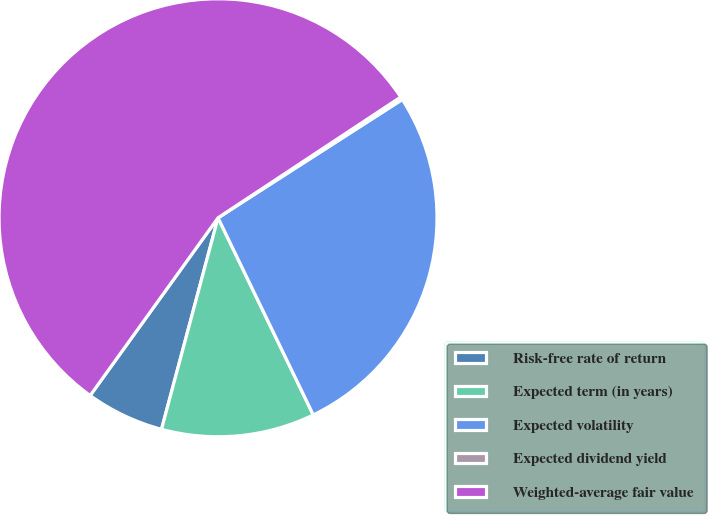Convert chart to OTSL. <chart><loc_0><loc_0><loc_500><loc_500><pie_chart><fcel>Risk-free rate of return<fcel>Expected term (in years)<fcel>Expected volatility<fcel>Expected dividend yield<fcel>Weighted-average fair value<nl><fcel>5.77%<fcel>11.32%<fcel>26.92%<fcel>0.21%<fcel>55.78%<nl></chart> 